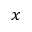<formula> <loc_0><loc_0><loc_500><loc_500>x</formula> 